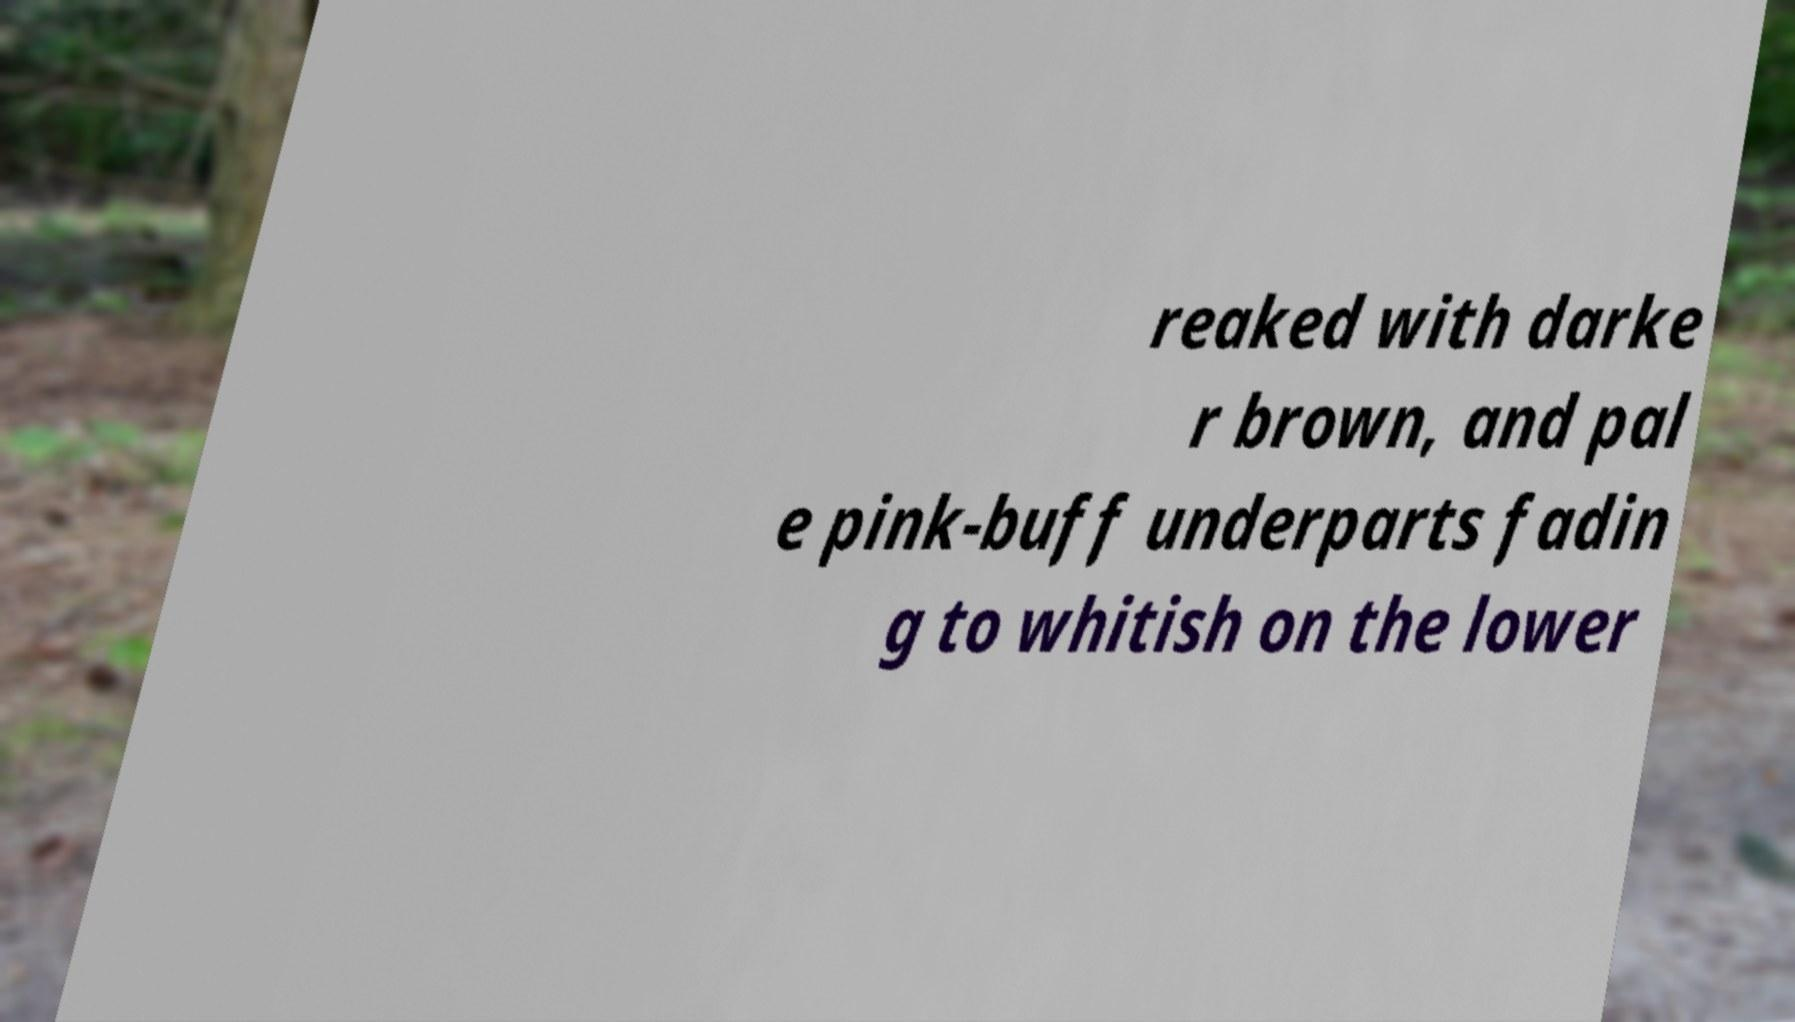Please identify and transcribe the text found in this image. reaked with darke r brown, and pal e pink-buff underparts fadin g to whitish on the lower 